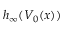Convert formula to latex. <formula><loc_0><loc_0><loc_500><loc_500>h _ { \infty } ( V _ { 0 } ( x ) )</formula> 